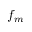<formula> <loc_0><loc_0><loc_500><loc_500>f _ { m }</formula> 